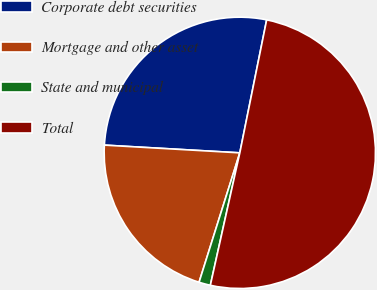<chart> <loc_0><loc_0><loc_500><loc_500><pie_chart><fcel>Corporate debt securities<fcel>Mortgage and other asset<fcel>State and municipal<fcel>Total<nl><fcel>27.26%<fcel>21.05%<fcel>1.37%<fcel>50.31%<nl></chart> 